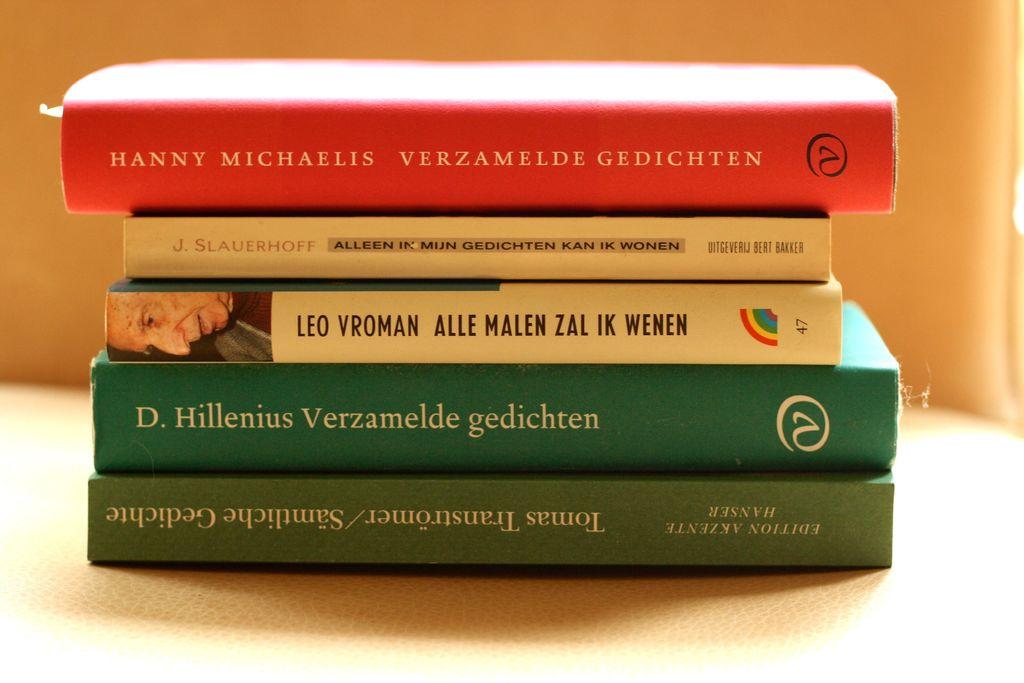Who wrote the green book?
Keep it short and to the point. D. hillenius. 